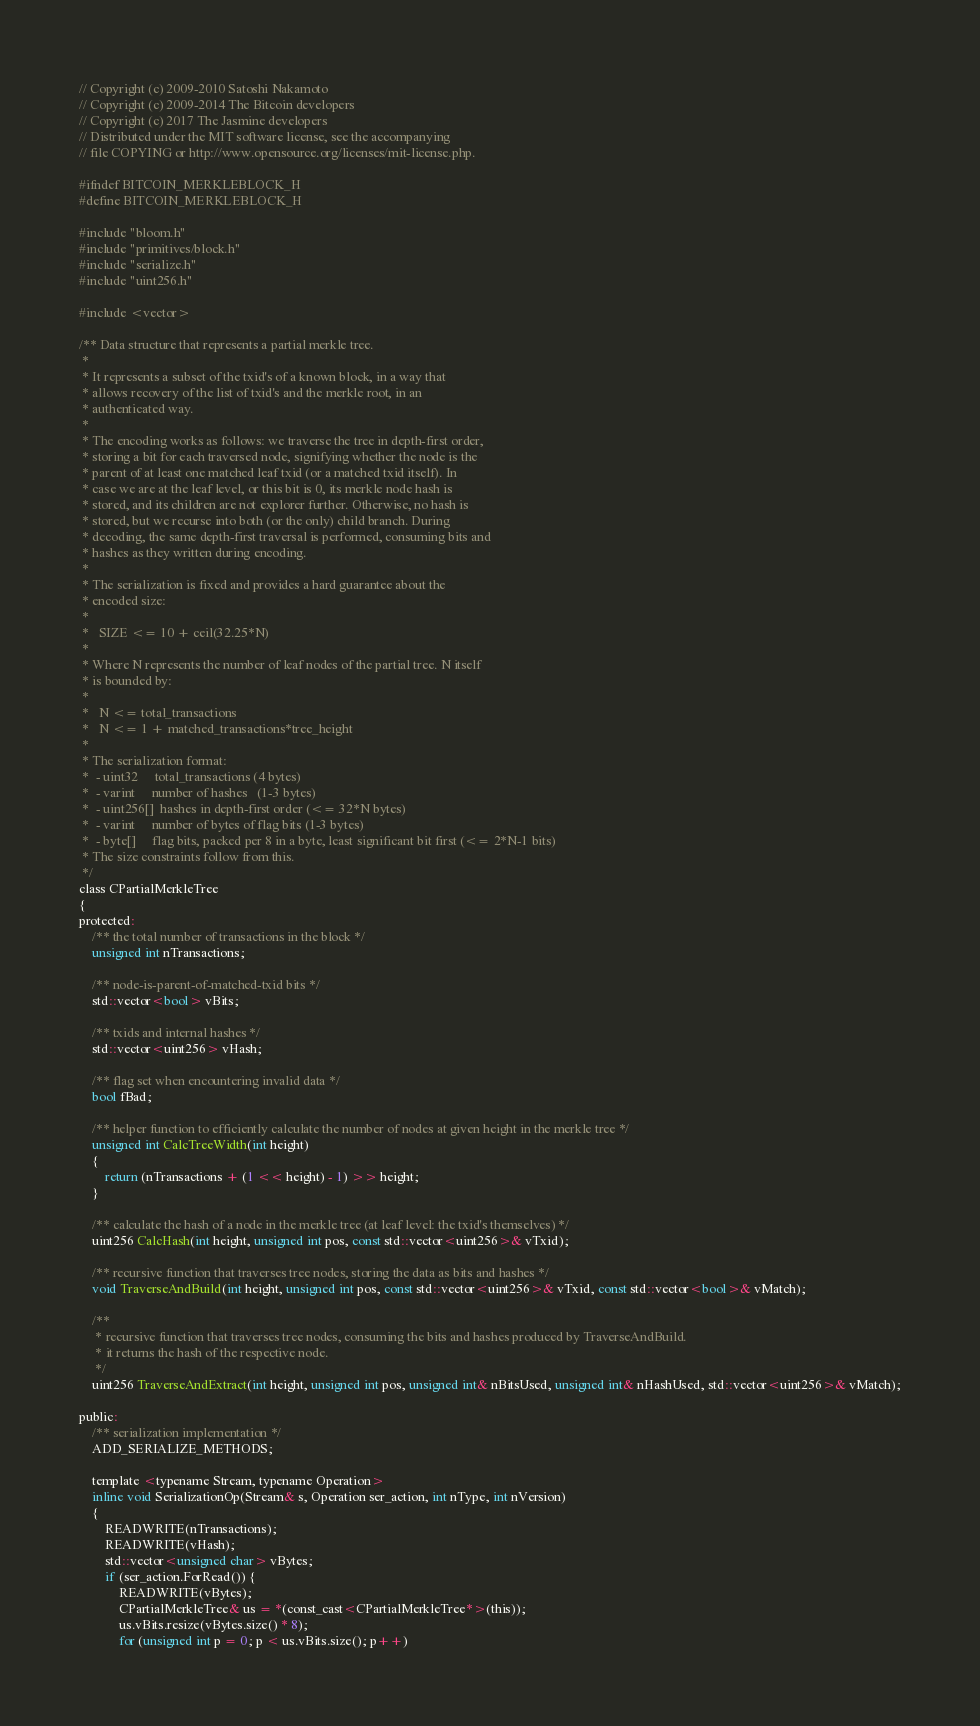Convert code to text. <code><loc_0><loc_0><loc_500><loc_500><_C_>// Copyright (c) 2009-2010 Satoshi Nakamoto
// Copyright (c) 2009-2014 The Bitcoin developers
// Copyright (c) 2017 The Jasmine developers
// Distributed under the MIT software license, see the accompanying
// file COPYING or http://www.opensource.org/licenses/mit-license.php.

#ifndef BITCOIN_MERKLEBLOCK_H
#define BITCOIN_MERKLEBLOCK_H

#include "bloom.h"
#include "primitives/block.h"
#include "serialize.h"
#include "uint256.h"

#include <vector>

/** Data structure that represents a partial merkle tree.
 *
 * It represents a subset of the txid's of a known block, in a way that
 * allows recovery of the list of txid's and the merkle root, in an
 * authenticated way.
 *
 * The encoding works as follows: we traverse the tree in depth-first order,
 * storing a bit for each traversed node, signifying whether the node is the
 * parent of at least one matched leaf txid (or a matched txid itself). In
 * case we are at the leaf level, or this bit is 0, its merkle node hash is
 * stored, and its children are not explorer further. Otherwise, no hash is
 * stored, but we recurse into both (or the only) child branch. During
 * decoding, the same depth-first traversal is performed, consuming bits and
 * hashes as they written during encoding.
 *
 * The serialization is fixed and provides a hard guarantee about the
 * encoded size:
 *
 *   SIZE <= 10 + ceil(32.25*N)
 *
 * Where N represents the number of leaf nodes of the partial tree. N itself
 * is bounded by:
 *
 *   N <= total_transactions
 *   N <= 1 + matched_transactions*tree_height
 *
 * The serialization format:
 *  - uint32     total_transactions (4 bytes)
 *  - varint     number of hashes   (1-3 bytes)
 *  - uint256[]  hashes in depth-first order (<= 32*N bytes)
 *  - varint     number of bytes of flag bits (1-3 bytes)
 *  - byte[]     flag bits, packed per 8 in a byte, least significant bit first (<= 2*N-1 bits)
 * The size constraints follow from this.
 */
class CPartialMerkleTree
{
protected:
    /** the total number of transactions in the block */
    unsigned int nTransactions;

    /** node-is-parent-of-matched-txid bits */
    std::vector<bool> vBits;

    /** txids and internal hashes */
    std::vector<uint256> vHash;

    /** flag set when encountering invalid data */
    bool fBad;

    /** helper function to efficiently calculate the number of nodes at given height in the merkle tree */
    unsigned int CalcTreeWidth(int height)
    {
        return (nTransactions + (1 << height) - 1) >> height;
    }

    /** calculate the hash of a node in the merkle tree (at leaf level: the txid's themselves) */
    uint256 CalcHash(int height, unsigned int pos, const std::vector<uint256>& vTxid);

    /** recursive function that traverses tree nodes, storing the data as bits and hashes */
    void TraverseAndBuild(int height, unsigned int pos, const std::vector<uint256>& vTxid, const std::vector<bool>& vMatch);

    /**
     * recursive function that traverses tree nodes, consuming the bits and hashes produced by TraverseAndBuild.
     * it returns the hash of the respective node.
     */
    uint256 TraverseAndExtract(int height, unsigned int pos, unsigned int& nBitsUsed, unsigned int& nHashUsed, std::vector<uint256>& vMatch);

public:
    /** serialization implementation */
    ADD_SERIALIZE_METHODS;

    template <typename Stream, typename Operation>
    inline void SerializationOp(Stream& s, Operation ser_action, int nType, int nVersion)
    {
        READWRITE(nTransactions);
        READWRITE(vHash);
        std::vector<unsigned char> vBytes;
        if (ser_action.ForRead()) {
            READWRITE(vBytes);
            CPartialMerkleTree& us = *(const_cast<CPartialMerkleTree*>(this));
            us.vBits.resize(vBytes.size() * 8);
            for (unsigned int p = 0; p < us.vBits.size(); p++)</code> 